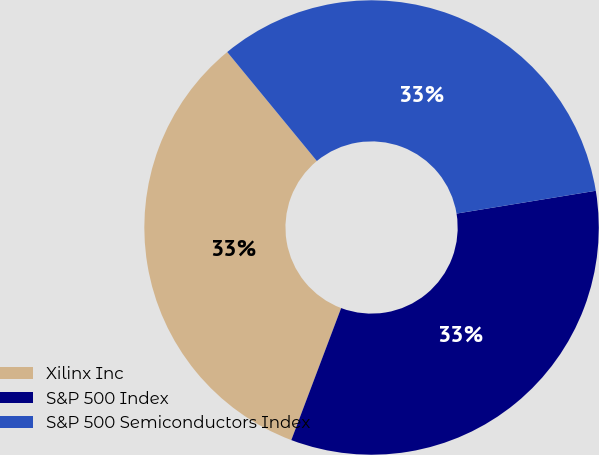Convert chart to OTSL. <chart><loc_0><loc_0><loc_500><loc_500><pie_chart><fcel>Xilinx Inc<fcel>S&P 500 Index<fcel>S&P 500 Semiconductors Index<nl><fcel>33.3%<fcel>33.33%<fcel>33.37%<nl></chart> 